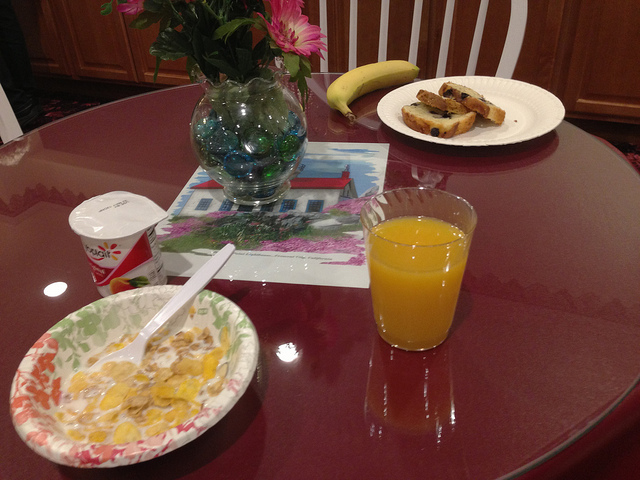I notice there's a container next to the bowl of cereal. What is it likely used for in the context of this breakfast? The container next to the bowl of cereal is a yogurt cup, which is often enjoyed with cereal or on its own. Yogurt provides a source of protein and can be mixed with cereal for additional texture and creaminess, or it might be used as a spread on the toast instead of traditional butter or jam. 